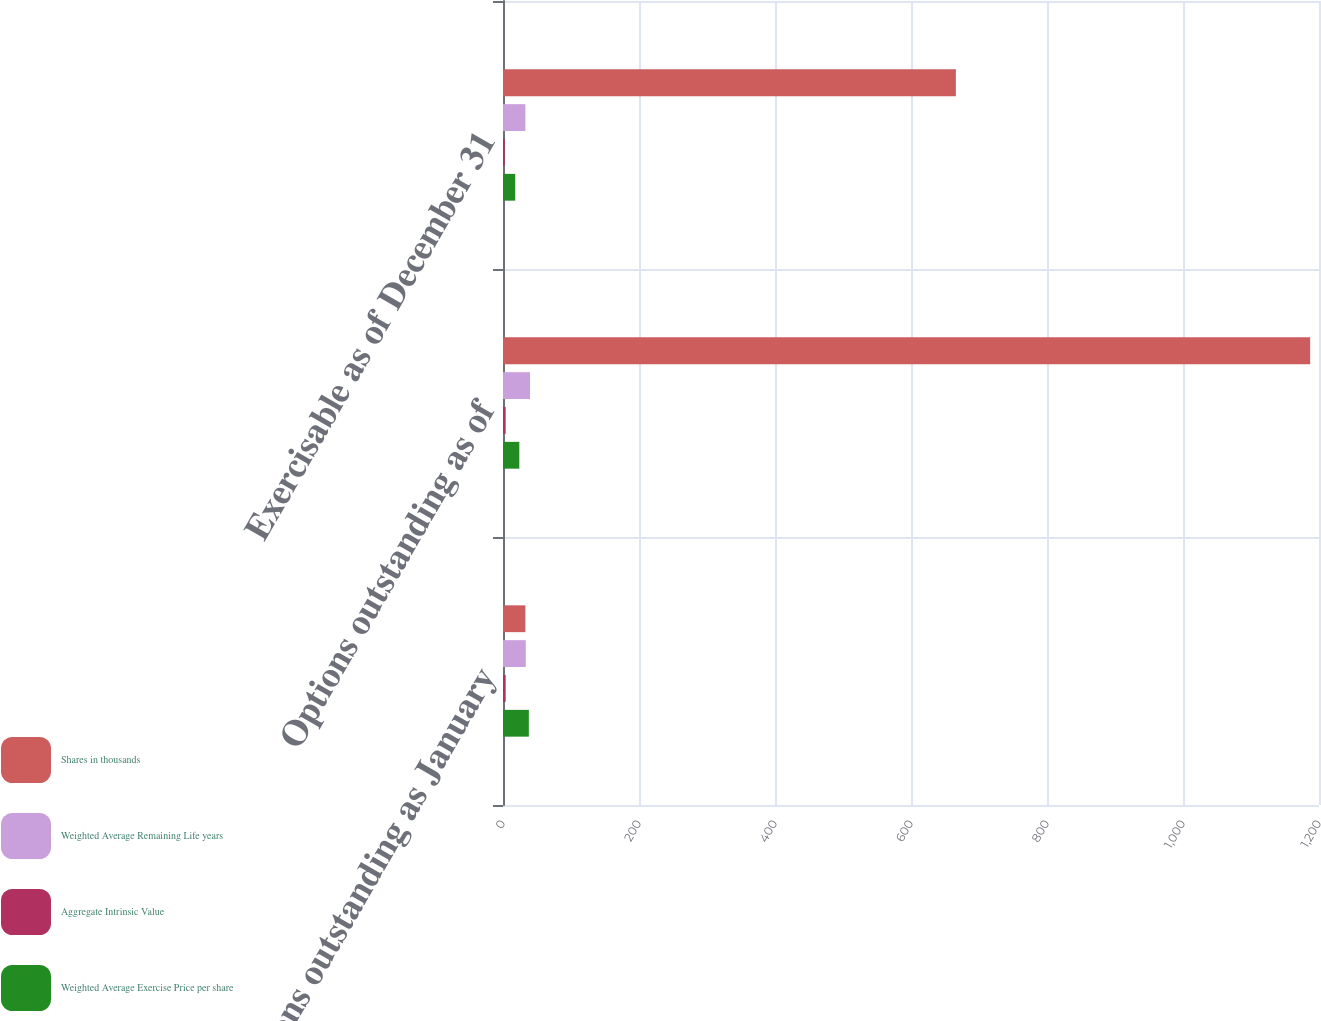<chart> <loc_0><loc_0><loc_500><loc_500><stacked_bar_chart><ecel><fcel>Options outstanding as January<fcel>Options outstanding as of<fcel>Exercisable as of December 31<nl><fcel>Shares in thousands<fcel>32.92<fcel>1187<fcel>666<nl><fcel>Weighted Average Remaining Life years<fcel>33.47<fcel>39.7<fcel>32.92<nl><fcel>Aggregate Intrinsic Value<fcel>3.9<fcel>3.9<fcel>2.6<nl><fcel>Weighted Average Exercise Price per share<fcel>38<fcel>24<fcel>18<nl></chart> 